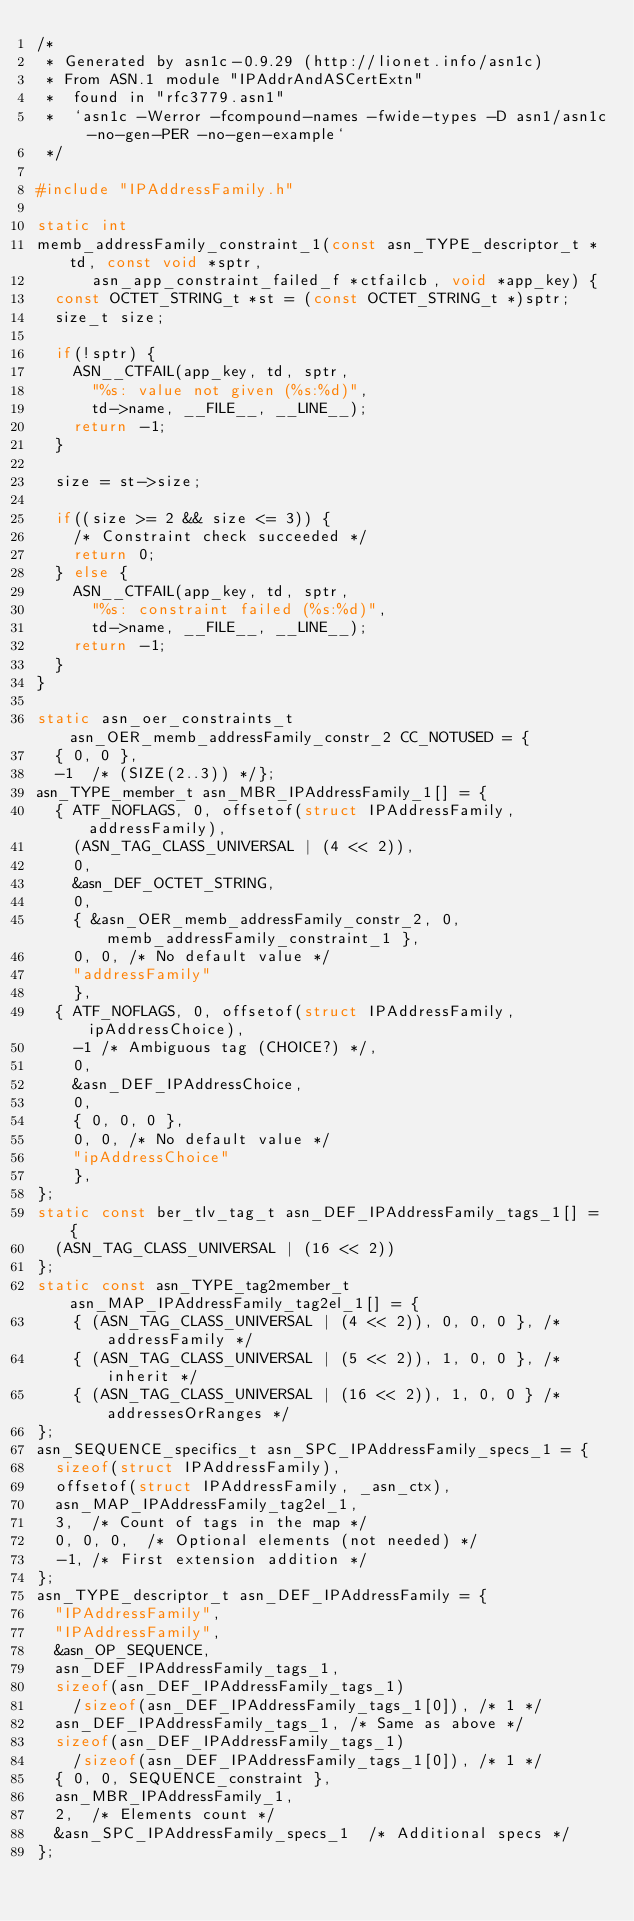<code> <loc_0><loc_0><loc_500><loc_500><_C_>/*
 * Generated by asn1c-0.9.29 (http://lionet.info/asn1c)
 * From ASN.1 module "IPAddrAndASCertExtn"
 * 	found in "rfc3779.asn1"
 * 	`asn1c -Werror -fcompound-names -fwide-types -D asn1/asn1c -no-gen-PER -no-gen-example`
 */

#include "IPAddressFamily.h"

static int
memb_addressFamily_constraint_1(const asn_TYPE_descriptor_t *td, const void *sptr,
			asn_app_constraint_failed_f *ctfailcb, void *app_key) {
	const OCTET_STRING_t *st = (const OCTET_STRING_t *)sptr;
	size_t size;
	
	if(!sptr) {
		ASN__CTFAIL(app_key, td, sptr,
			"%s: value not given (%s:%d)",
			td->name, __FILE__, __LINE__);
		return -1;
	}
	
	size = st->size;
	
	if((size >= 2 && size <= 3)) {
		/* Constraint check succeeded */
		return 0;
	} else {
		ASN__CTFAIL(app_key, td, sptr,
			"%s: constraint failed (%s:%d)",
			td->name, __FILE__, __LINE__);
		return -1;
	}
}

static asn_oer_constraints_t asn_OER_memb_addressFamily_constr_2 CC_NOTUSED = {
	{ 0, 0 },
	-1	/* (SIZE(2..3)) */};
asn_TYPE_member_t asn_MBR_IPAddressFamily_1[] = {
	{ ATF_NOFLAGS, 0, offsetof(struct IPAddressFamily, addressFamily),
		(ASN_TAG_CLASS_UNIVERSAL | (4 << 2)),
		0,
		&asn_DEF_OCTET_STRING,
		0,
		{ &asn_OER_memb_addressFamily_constr_2, 0,  memb_addressFamily_constraint_1 },
		0, 0, /* No default value */
		"addressFamily"
		},
	{ ATF_NOFLAGS, 0, offsetof(struct IPAddressFamily, ipAddressChoice),
		-1 /* Ambiguous tag (CHOICE?) */,
		0,
		&asn_DEF_IPAddressChoice,
		0,
		{ 0, 0, 0 },
		0, 0, /* No default value */
		"ipAddressChoice"
		},
};
static const ber_tlv_tag_t asn_DEF_IPAddressFamily_tags_1[] = {
	(ASN_TAG_CLASS_UNIVERSAL | (16 << 2))
};
static const asn_TYPE_tag2member_t asn_MAP_IPAddressFamily_tag2el_1[] = {
    { (ASN_TAG_CLASS_UNIVERSAL | (4 << 2)), 0, 0, 0 }, /* addressFamily */
    { (ASN_TAG_CLASS_UNIVERSAL | (5 << 2)), 1, 0, 0 }, /* inherit */
    { (ASN_TAG_CLASS_UNIVERSAL | (16 << 2)), 1, 0, 0 } /* addressesOrRanges */
};
asn_SEQUENCE_specifics_t asn_SPC_IPAddressFamily_specs_1 = {
	sizeof(struct IPAddressFamily),
	offsetof(struct IPAddressFamily, _asn_ctx),
	asn_MAP_IPAddressFamily_tag2el_1,
	3,	/* Count of tags in the map */
	0, 0, 0,	/* Optional elements (not needed) */
	-1,	/* First extension addition */
};
asn_TYPE_descriptor_t asn_DEF_IPAddressFamily = {
	"IPAddressFamily",
	"IPAddressFamily",
	&asn_OP_SEQUENCE,
	asn_DEF_IPAddressFamily_tags_1,
	sizeof(asn_DEF_IPAddressFamily_tags_1)
		/sizeof(asn_DEF_IPAddressFamily_tags_1[0]), /* 1 */
	asn_DEF_IPAddressFamily_tags_1,	/* Same as above */
	sizeof(asn_DEF_IPAddressFamily_tags_1)
		/sizeof(asn_DEF_IPAddressFamily_tags_1[0]), /* 1 */
	{ 0, 0, SEQUENCE_constraint },
	asn_MBR_IPAddressFamily_1,
	2,	/* Elements count */
	&asn_SPC_IPAddressFamily_specs_1	/* Additional specs */
};

</code> 